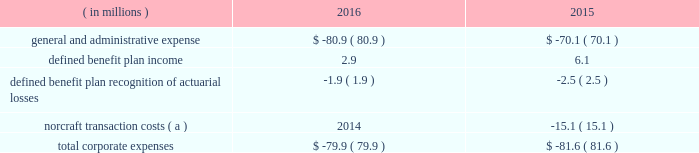Corporate corporate expenses in 2016 benefited from the absence of transaction costs associated with the norcraft acquisition ( $ 15.1 million in 2015 ) .
This benefit was offset by higher employee-related costs and lower defined benefit plan income .
( in millions ) 2016 2015 .
( a ) represents external costs directly related to the acquisition of norcraft and primarily includes expenditures for banking , legal , accounting and other similar services .
In future periods the company may record , in the corporate segment , material expense or income associated with actuarial gains and losses arising from periodic remeasurement of our liabilities for defined benefit plans .
At a minimum the company will remeasure its defined benefit plan liabilities in the fourth quarter of each year .
Remeasurements due to plan amendments and settlements may also occur in interim periods during the year .
Remeasurement of these liabilities attributable to updating our liability discount rates and expected return on assets may , in particular , result in material income or expense recognition .
Liquidity and capital resources our primary liquidity needs are to support working capital requirements , fund capital expenditures and service indebtedness , as well as to finance acquisitions , repurchase shares of our common stock and pay dividends to stockholders , as deemed appropriate .
Our principal sources of liquidity are cash on hand , cash flows from operating activities , availability under our credit facility and debt issuances in the capital markets .
Our operating income is generated by our subsidiaries .
There are no restrictions on the ability of our subsidiaries to pay dividends or make other distributions to fortune brands .
In december 2017 , our board of directors increased the quarterly cash dividend by 11% ( 11 % ) to $ 0.20 per share of our common stock .
Our board of directors will continue to evaluate dividend payment opportunities on a quarterly basis .
There can be no assurance as to when and if future dividends will be paid , and at what level , because the payment of dividends is dependent on our financial condition , results of operations , cash flows , capital requirements and other factors deemed relevant by our board of directors .
We periodically review our portfolio of brands and evaluate potential strategic transactions to increase shareholder value .
However , we cannot predict whether or when we may enter into acquisitions , joint ventures or dispositions , make any purchases of shares of our common stock under our share repurchase program , or pay dividends , or what impact any such transactions could have on our results of operations , cash flows or financial condition , whether as a result of the issuance of debt or equity securities , or otherwise .
Our cash flows from operations , borrowing availability and overall liquidity are subject to certain risks and uncertainties , including those described in the section 201citem 1a .
Risk factors . 201d in june 2016 , the company amended and restated its credit agreement to combine and rollover the existing revolving credit facility and term loan into a new standalone $ 1.25 billion revolving credit facility .
This amendment and restatement of the credit agreement was a non-cash transaction for the company .
Terms and conditions of the credit agreement , including the total commitment amount , essentially remained the same as under the 2011 credit agreement .
The revolving credit facility will mature in june 2021 and borrowings thereunder will be used for general corporate purposes .
On december 31 , 2017 and december 31 , 2016 , our outstanding borrowings under these facilities were $ 615.0 million and $ 540.0 million , respectively .
At december 31 , 2017 and december 31 , 2016 , the current portion of long- term debt was zero .
Interest rates under the facility are variable based on libor at the time of the .
What was the percentage growth in the general and administrative expense from 2015 to 2016? 
Computations: ((80.9 - 70.1) / 70.1)
Answer: 0.15407. 